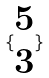Convert formula to latex. <formula><loc_0><loc_0><loc_500><loc_500>\{ \begin{matrix} 5 \\ 3 \end{matrix} \}</formula> 